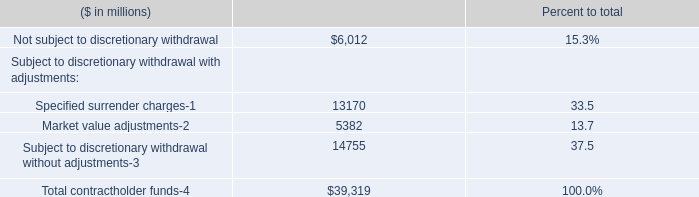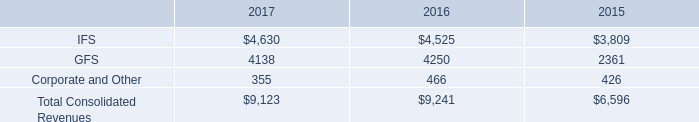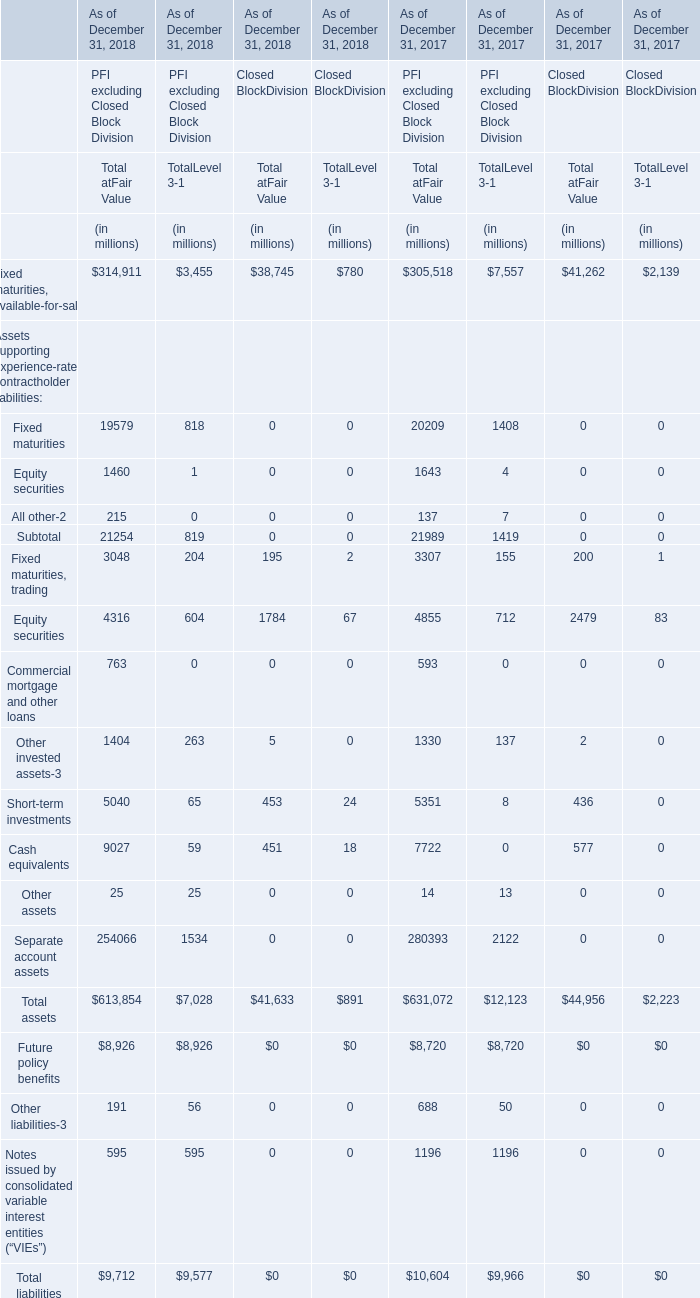what is the growth rate in consolidated revenues from 2016 to 2017? 
Computations: ((9123 - 9241) / 9241)
Answer: -0.01277. 